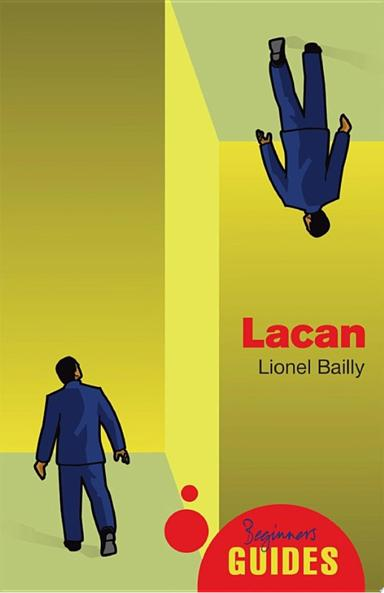What is the significance of the upside-down figure on the cover? The upside-down figure on the cover symbolically represents the inversion of normal perspectives, a core concept in Lacan's psychoanalytic theories which often challenge conventional views of reality and self. 